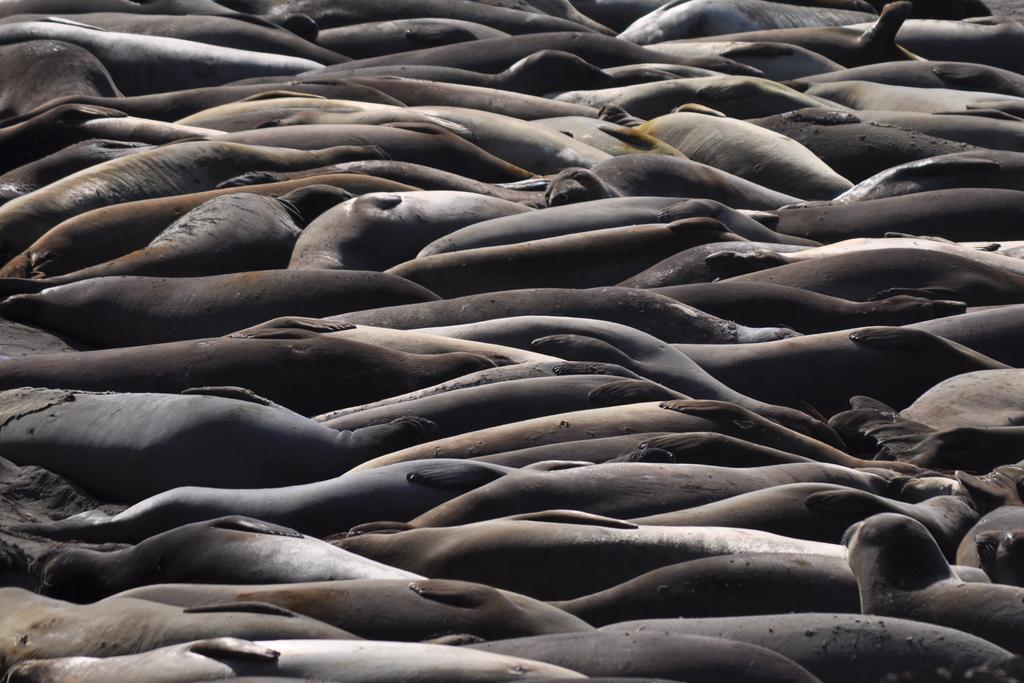How would you summarize this image in a sentence or two? In this image there are a number of seals.   